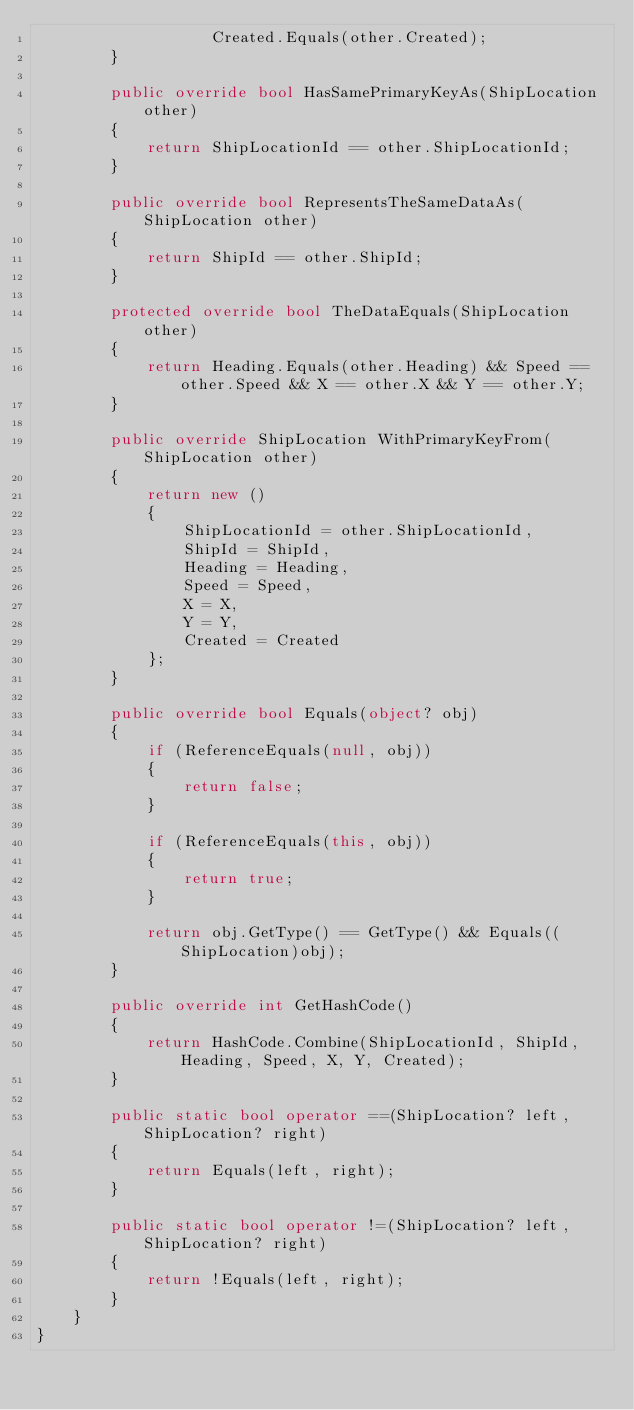Convert code to text. <code><loc_0><loc_0><loc_500><loc_500><_C#_>			       Created.Equals(other.Created);
		}

		public override bool HasSamePrimaryKeyAs(ShipLocation other)
		{
			return ShipLocationId == other.ShipLocationId;
		}

		public override bool RepresentsTheSameDataAs(ShipLocation other)
		{
			return ShipId == other.ShipId;
		}

		protected override bool TheDataEquals(ShipLocation other)
		{
			return Heading.Equals(other.Heading) && Speed == other.Speed && X == other.X && Y == other.Y;
		}

		public override ShipLocation WithPrimaryKeyFrom(ShipLocation other)
		{
			return new ()
			{
				ShipLocationId = other.ShipLocationId,
				ShipId = ShipId,
				Heading = Heading,
				Speed = Speed,
				X = X,
				Y = Y,
				Created = Created
			};
		}

		public override bool Equals(object? obj)
		{
			if (ReferenceEquals(null, obj))
			{
				return false;
			}

			if (ReferenceEquals(this, obj))
			{
				return true;
			}

			return obj.GetType() == GetType() && Equals((ShipLocation)obj);
		}

		public override int GetHashCode()
		{
			return HashCode.Combine(ShipLocationId, ShipId, Heading, Speed, X, Y, Created);
		}

		public static bool operator ==(ShipLocation? left, ShipLocation? right)
		{
			return Equals(left, right);
		}

		public static bool operator !=(ShipLocation? left, ShipLocation? right)
		{
			return !Equals(left, right);
		}
	}
}</code> 